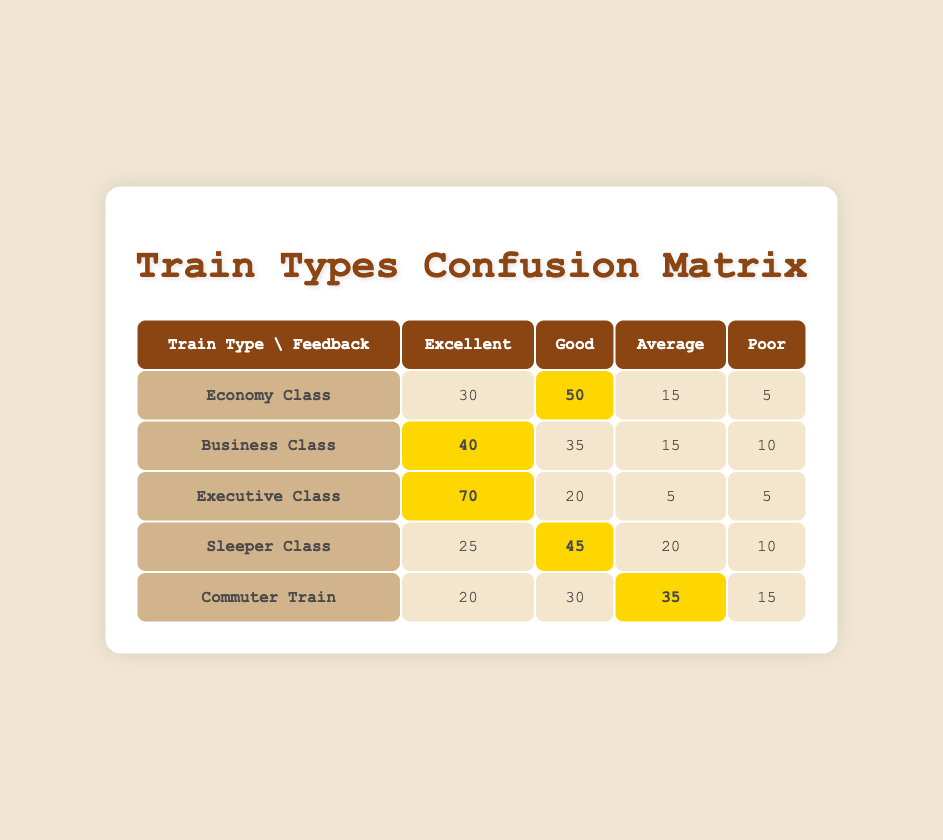What is the highest number of "Excellent" ratings among the train types? The "Executive Class" has the highest number of "Excellent" ratings with 70. This can be found by comparing the values in the "Excellent" column for each train type.
Answer: 70 How many "Good" ratings does the Economy Class have? The Economy Class has 50 "Good" ratings, which is directly listed in the table under the "Good" column for that row.
Answer: 50 What is the sum of "Poor" ratings across all train types? The "Poor" ratings are 5 (Economy), 10 (Business), 5 (Executive), 10 (Sleeper), and 15 (Commuter). Adding these gives 5 + 10 + 5 + 10 + 15 = 45.
Answer: 45 Which train type has the lowest number of "Average" ratings? The "Executive Class" has the lowest number of "Average" ratings with only 5. This row is checked for the "Average" column values, and the minimum is determined.
Answer: Executive Class Do more passengers rate the Sleeper Class as "Excellent" than the Commuter Train? The Sleeper Class has 25 "Excellent" ratings, while the Commuter Train has 20. Since 25 is greater than 20, the statement is true.
Answer: Yes What is the average number of "Good" ratings across all train types? The "Good" ratings are: 50 (Economy), 35 (Business), 20 (Executive), 45 (Sleeper), and 30 (Commuter). Summing these gives 50 + 35 + 20 + 45 + 30 = 180. There are 5 train types, so the average is 180 / 5 = 36.
Answer: 36 Is it true that more than half of the ratings for the Executive Class are "Excellent"? The Executive Class received 70 "Excellent" ratings out of a total of 100 ratings (70 + 20 + 5 + 5). Since 70 is indeed more than half of 100, the statement is true.
Answer: Yes Which train type has the greatest difference between "Excellent" and "Poor" ratings? The difference can be calculated for each type: Economy: 30-5=25, Business: 40-10=30, Executive: 70-5=65, Sleeper: 25-10=15, Commuter: 20-15=5. The greatest difference is with the Executive Class, which has a difference of 65.
Answer: Executive Class How many train types received at least 40 "Good" ratings? The train types with "Good" ratings of at least 40 are Economy Class (50), Business Class (35), Executive Class (20), and Sleeper Class (45). Examining the data shows that only the Sleeper Class qualifies. So, the total is 3.
Answer: 3 